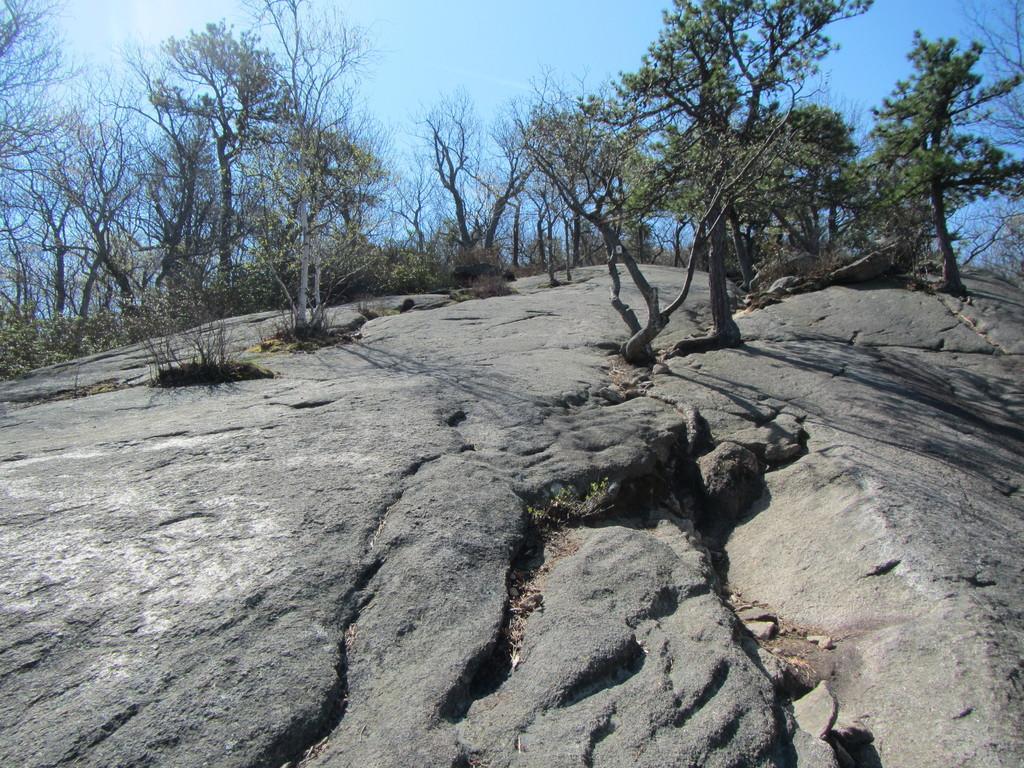Can you describe this image briefly? There are some trees on the mountain and there is a blue sky at the top of this image. 